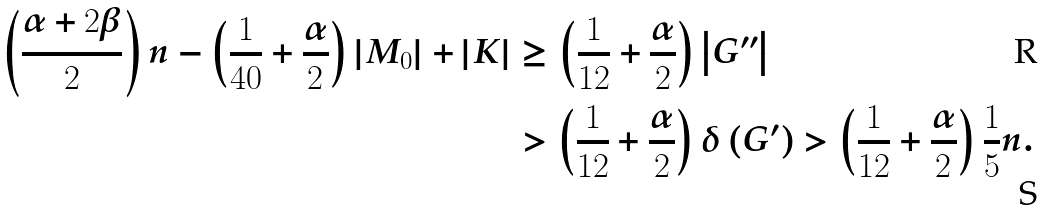<formula> <loc_0><loc_0><loc_500><loc_500>\left ( \frac { \alpha + 2 \beta } { 2 } \right ) n - \left ( \frac { 1 } { 4 0 } + \frac { \alpha } { 2 } \right ) \left | M _ { 0 } \right | + \left | K \right | & \geq \left ( \frac { 1 } { 1 2 } + \frac { \alpha } { 2 } \right ) \left | G ^ { \prime \prime } \right | \\ & > \left ( \frac { 1 } { 1 2 } + \frac { \alpha } { 2 } \right ) \delta \left ( G ^ { \prime } \right ) > \left ( \frac { 1 } { 1 2 } + \frac { \alpha } { 2 } \right ) \frac { 1 } { 5 } n .</formula> 